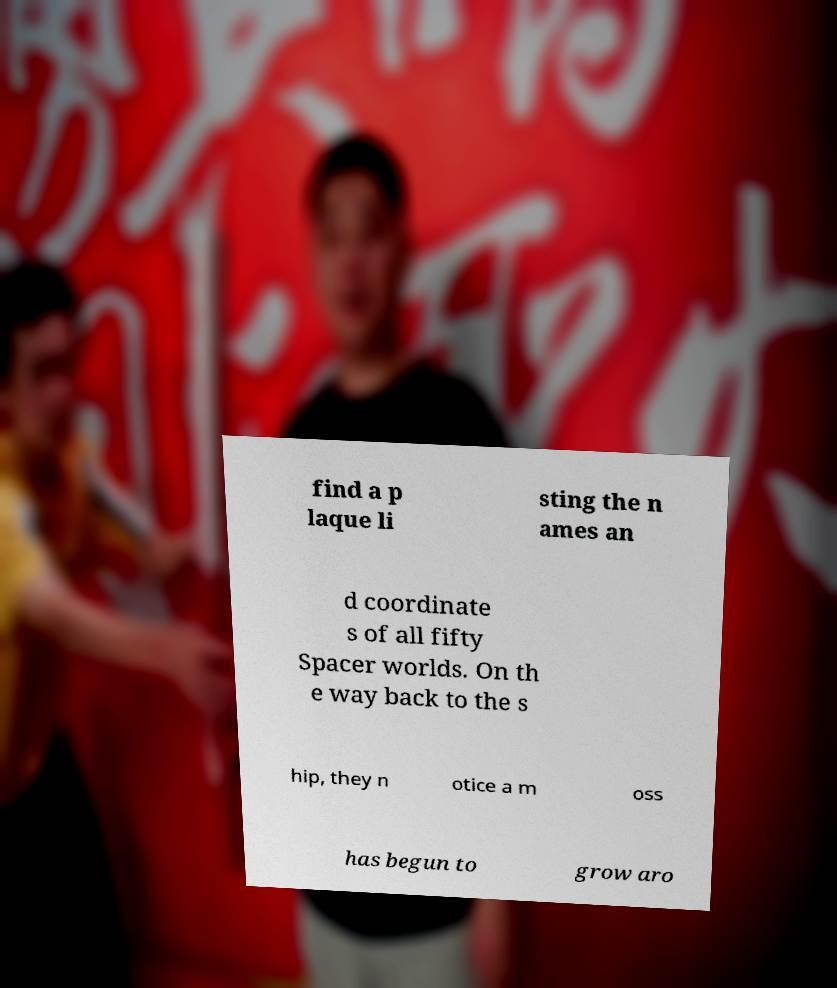Could you extract and type out the text from this image? find a p laque li sting the n ames an d coordinate s of all fifty Spacer worlds. On th e way back to the s hip, they n otice a m oss has begun to grow aro 